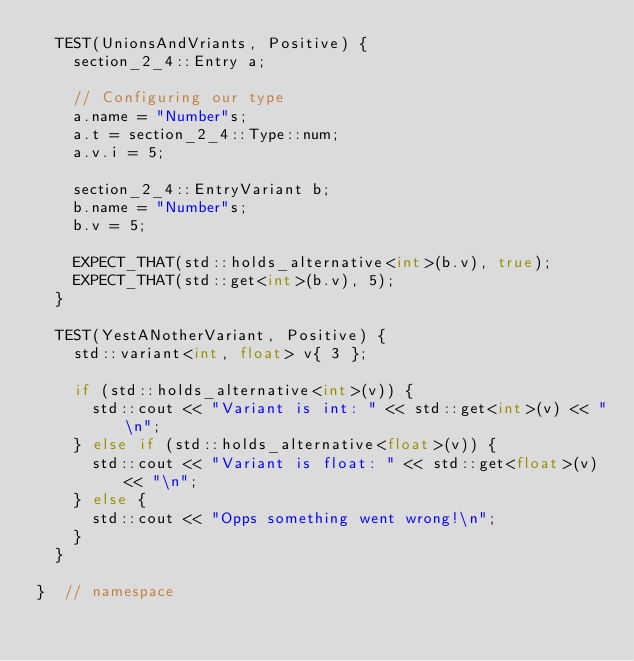Convert code to text. <code><loc_0><loc_0><loc_500><loc_500><_C++_>  TEST(UnionsAndVriants, Positive) {
    section_2_4::Entry a;

    // Configuring our type
    a.name = "Number"s;
    a.t = section_2_4::Type::num;
    a.v.i = 5;

    section_2_4::EntryVariant b;
    b.name = "Number"s;
    b.v = 5;

    EXPECT_THAT(std::holds_alternative<int>(b.v), true);
    EXPECT_THAT(std::get<int>(b.v), 5);
  }

  TEST(YestANotherVariant, Positive) {
    std::variant<int, float> v{ 3 };

    if (std::holds_alternative<int>(v)) {
      std::cout << "Variant is int: " << std::get<int>(v) << "\n";
    } else if (std::holds_alternative<float>(v)) {
      std::cout << "Variant is float: " << std::get<float>(v) << "\n";
    } else {
      std::cout << "Opps something went wrong!\n";
    }
  }

}  // namespace
</code> 